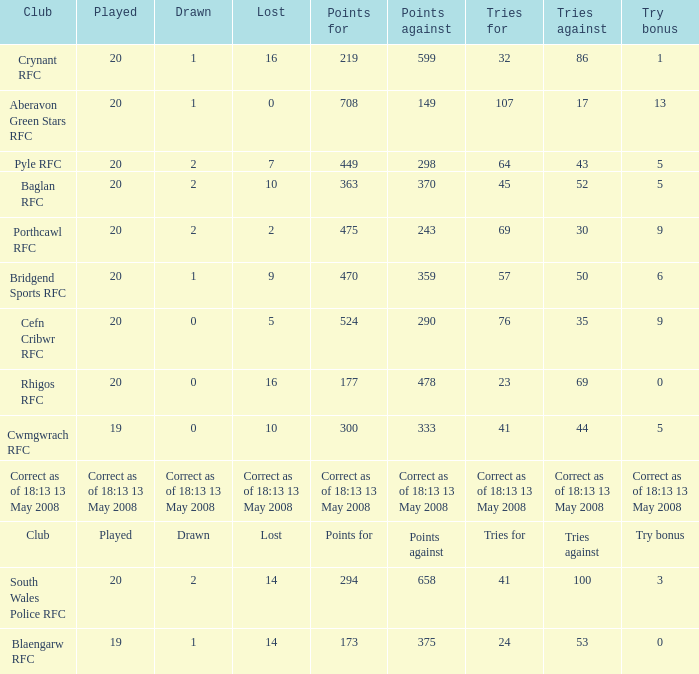What club has a played number of 19, and the lost of 14? Blaengarw RFC. 